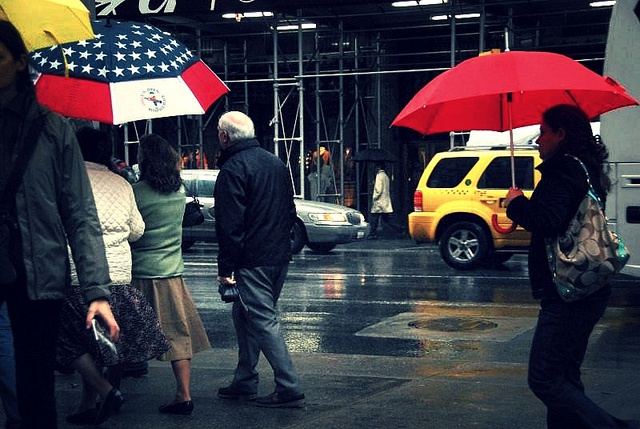Describe the objects in this image and their specific colors. I can see people in khaki, black, navy, gray, and blue tones, people in khaki, black, darkblue, gray, and blue tones, people in khaki, black, navy, gray, and blue tones, umbrella in khaki, ivory, navy, brown, and black tones, and people in khaki, black, beige, and gray tones in this image. 